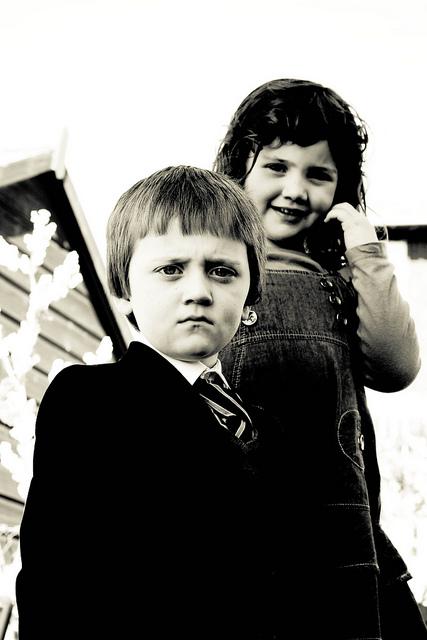Does the little boy in this picture look unhappy?
Be succinct. Yes. Are the boy and girl both in formal attire?
Write a very short answer. No. Is there a building behind the children?
Short answer required. Yes. 